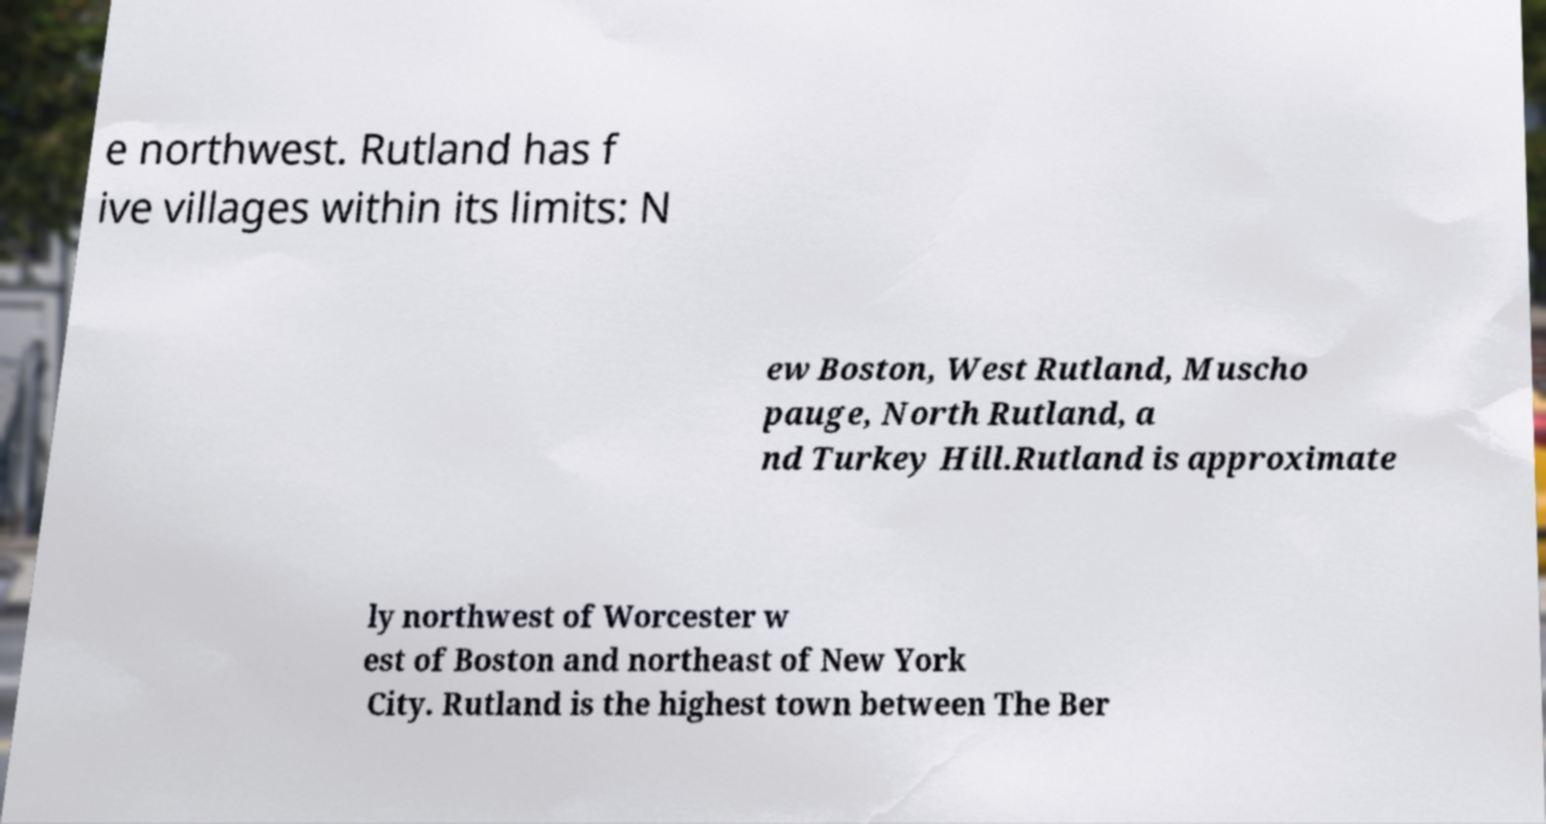What messages or text are displayed in this image? I need them in a readable, typed format. e northwest. Rutland has f ive villages within its limits: N ew Boston, West Rutland, Muscho pauge, North Rutland, a nd Turkey Hill.Rutland is approximate ly northwest of Worcester w est of Boston and northeast of New York City. Rutland is the highest town between The Ber 